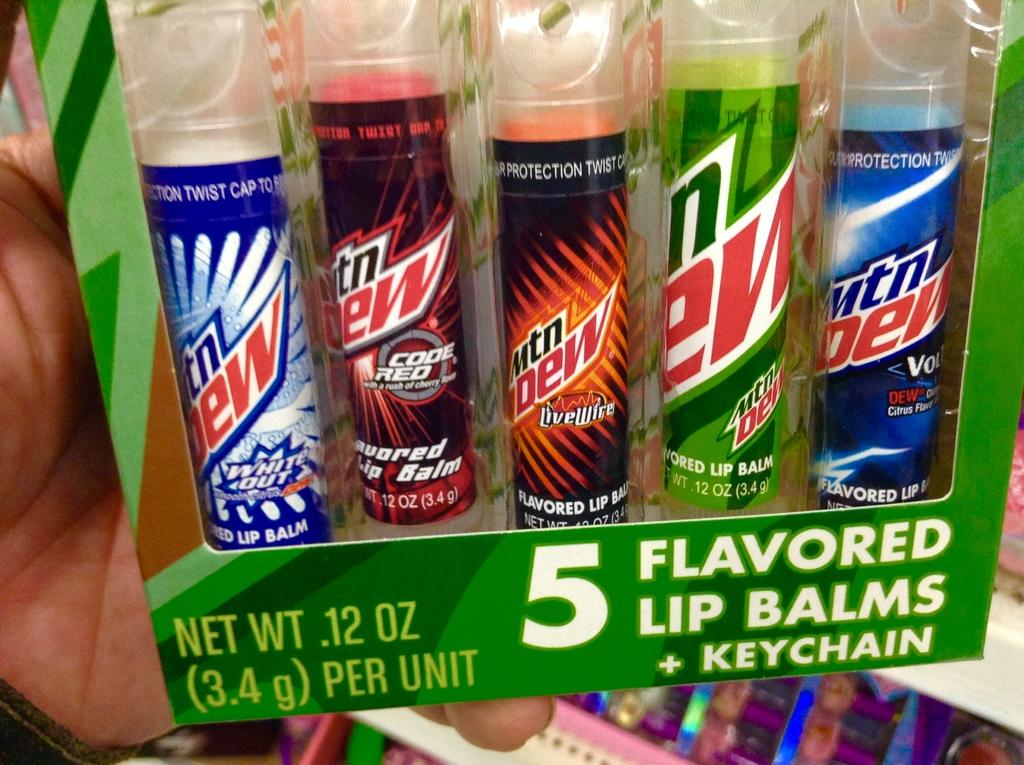<image>
Offer a succinct explanation of the picture presented. A package of Mountain Dew flavored lip balms with keychains. 